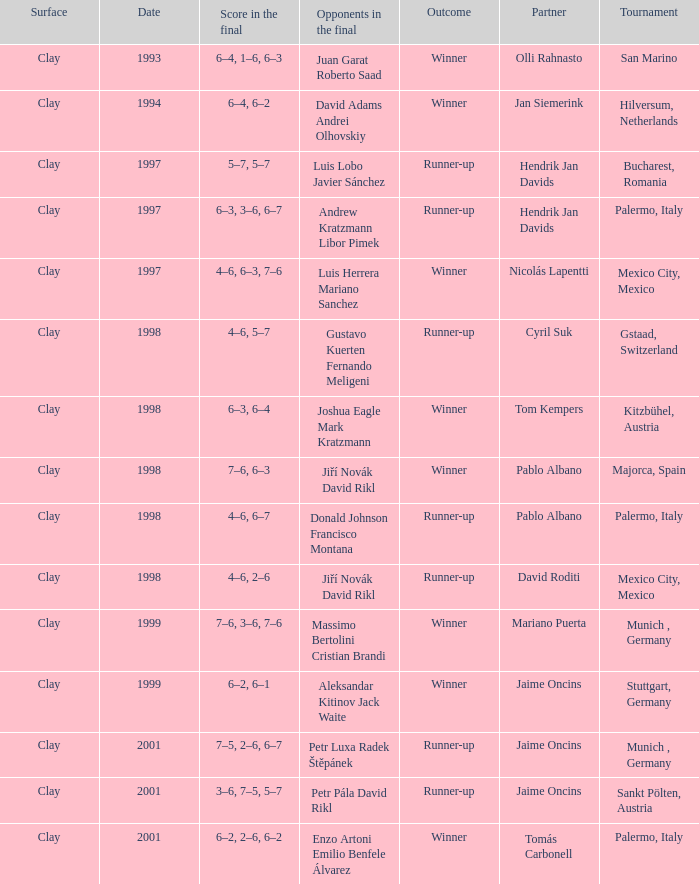Who are the Opponents in the final prior to 1998 in the Bucharest, Romania Tournament? Luis Lobo Javier Sánchez. 